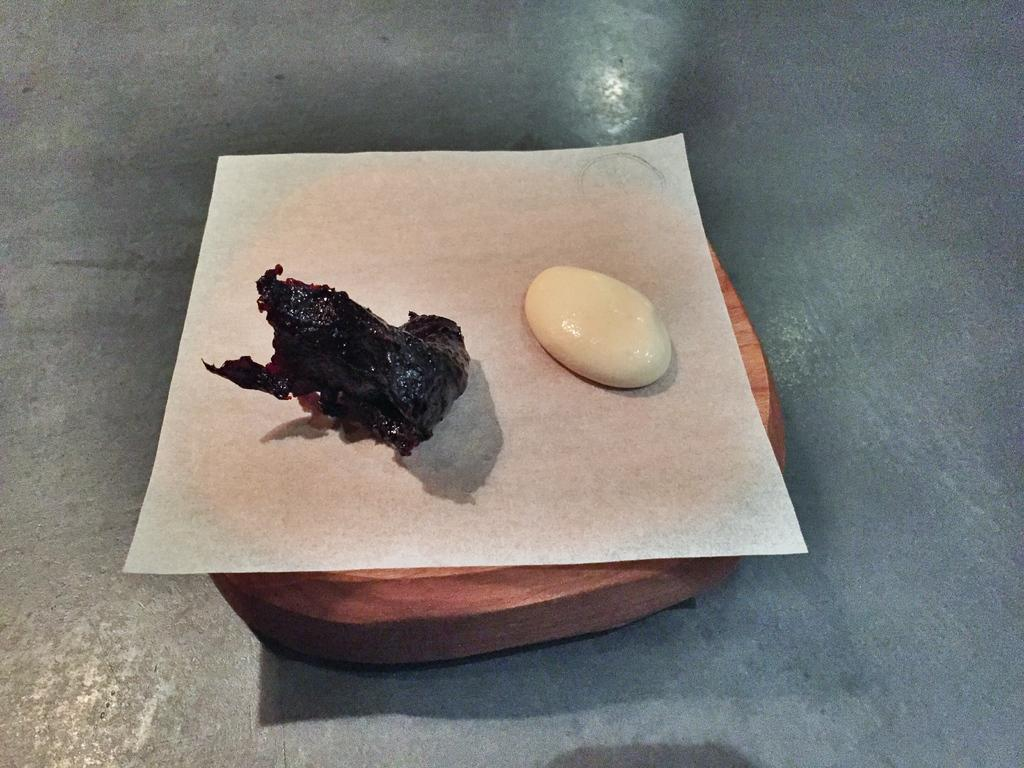How many objects are visible in the image? There are two objects in the image. What is the surface on which the objects are placed? The two objects are placed on a white paper. What is the material of the object that supports the white paper? The white paper is on a wooden object. Are there any plants growing on the wooden object in the image? There are no plants visible in the image; it only shows two objects placed on a white paper on a wooden object. 